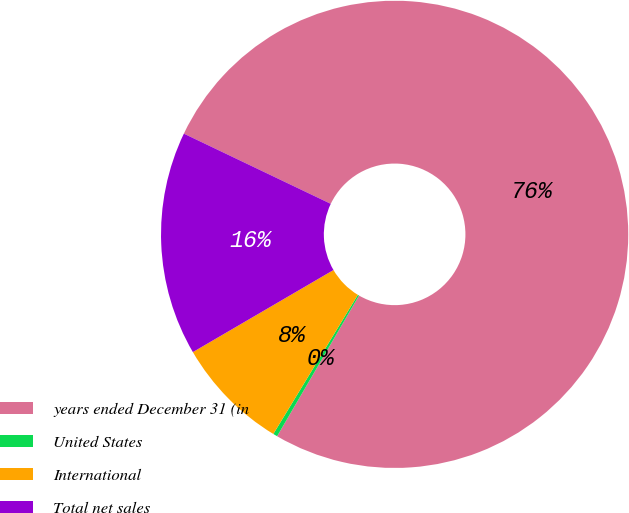<chart> <loc_0><loc_0><loc_500><loc_500><pie_chart><fcel>years ended December 31 (in<fcel>United States<fcel>International<fcel>Total net sales<nl><fcel>76.29%<fcel>0.3%<fcel>7.9%<fcel>15.5%<nl></chart> 